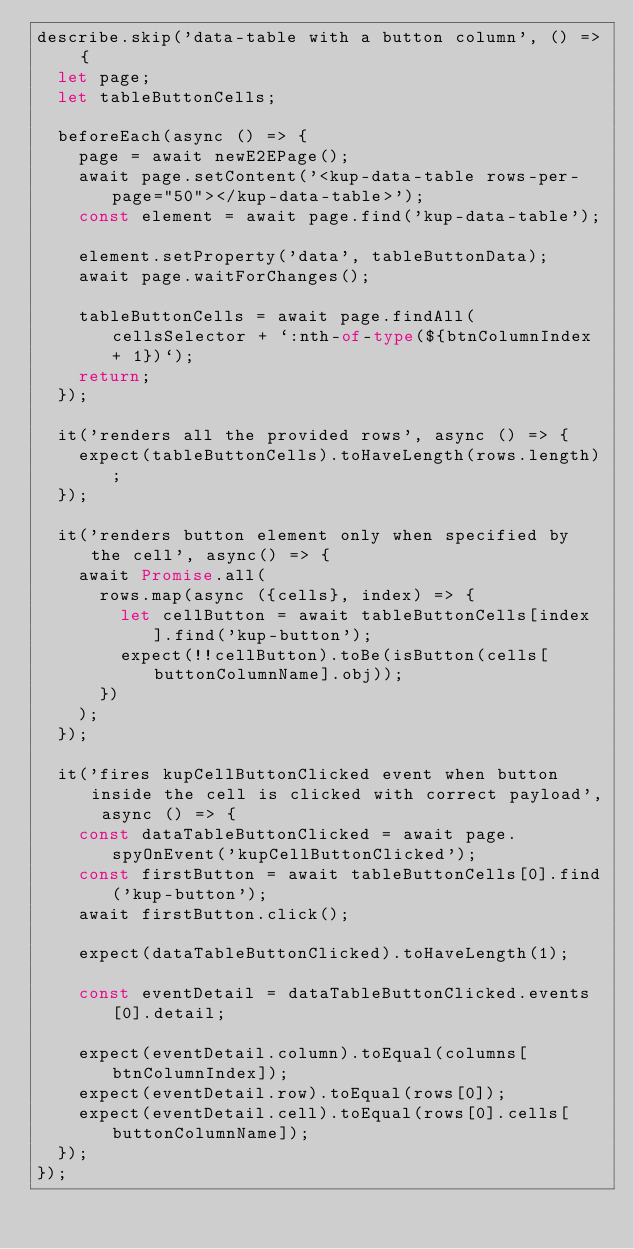<code> <loc_0><loc_0><loc_500><loc_500><_TypeScript_>describe.skip('data-table with a button column', () => {
  let page;
  let tableButtonCells;

  beforeEach(async () => {
    page = await newE2EPage();
    await page.setContent('<kup-data-table rows-per-page="50"></kup-data-table>');
    const element = await page.find('kup-data-table');

    element.setProperty('data', tableButtonData);
    await page.waitForChanges();

    tableButtonCells = await page.findAll(cellsSelector + `:nth-of-type(${btnColumnIndex + 1})`);
    return;
  });

  it('renders all the provided rows', async () => {
    expect(tableButtonCells).toHaveLength(rows.length);
  });

  it('renders button element only when specified by the cell', async() => {
    await Promise.all(
      rows.map(async ({cells}, index) => {
        let cellButton = await tableButtonCells[index].find('kup-button');
        expect(!!cellButton).toBe(isButton(cells[buttonColumnName].obj));
      })
    );
  });

  it('fires kupCellButtonClicked event when button inside the cell is clicked with correct payload', async () => {
    const dataTableButtonClicked = await page.spyOnEvent('kupCellButtonClicked');
    const firstButton = await tableButtonCells[0].find('kup-button');
    await firstButton.click();

    expect(dataTableButtonClicked).toHaveLength(1);

    const eventDetail = dataTableButtonClicked.events[0].detail;

    expect(eventDetail.column).toEqual(columns[btnColumnIndex]);
    expect(eventDetail.row).toEqual(rows[0]);
    expect(eventDetail.cell).toEqual(rows[0].cells[buttonColumnName]);
  });
});
</code> 